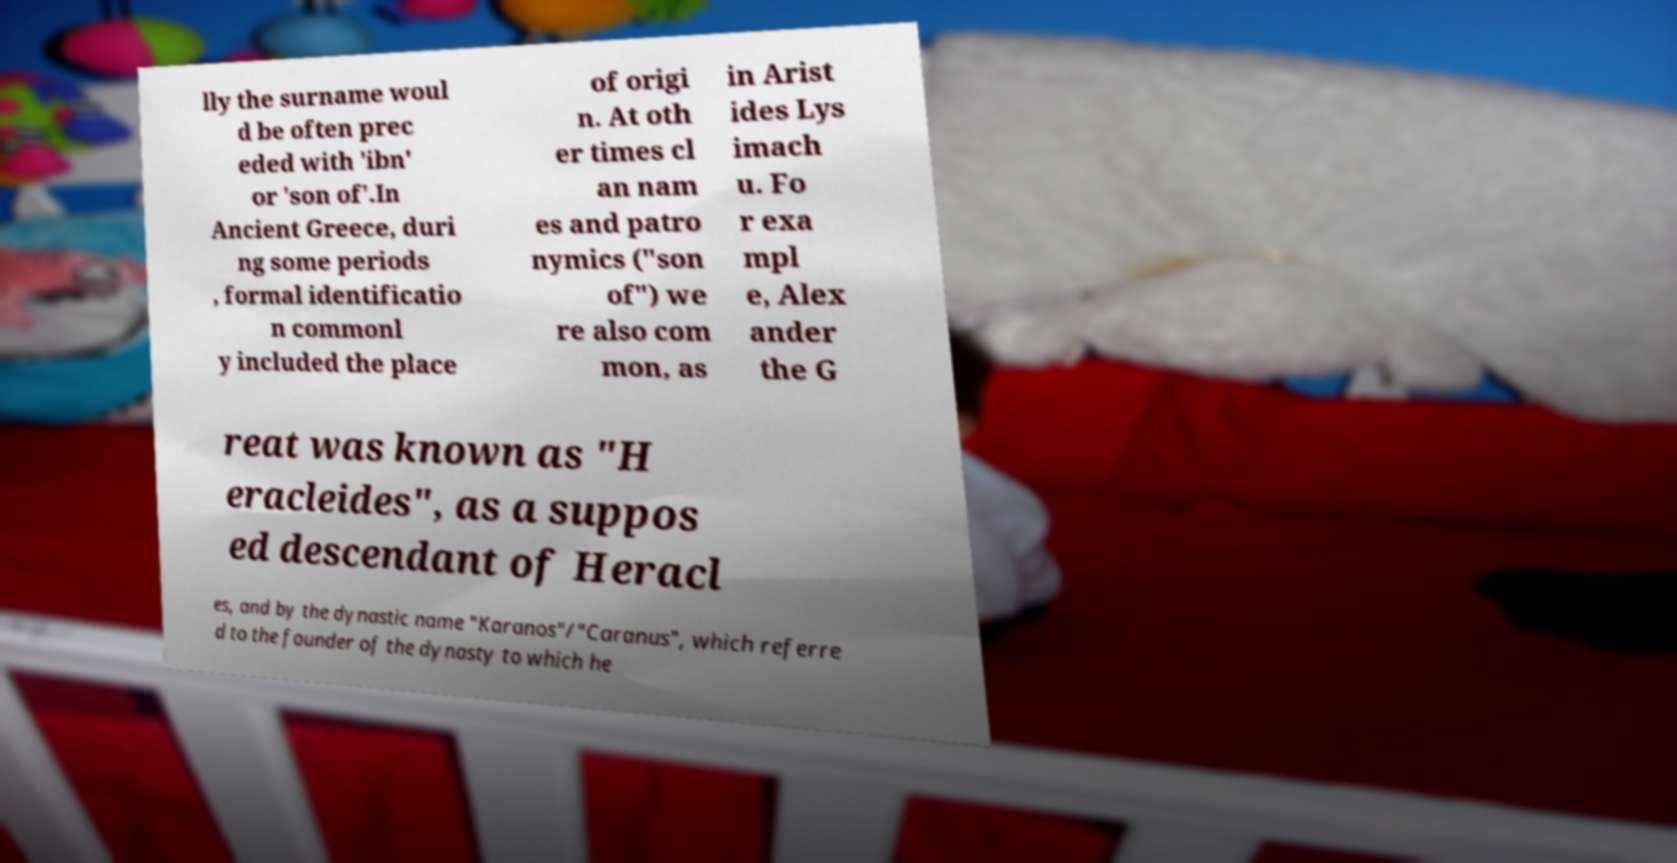Could you extract and type out the text from this image? lly the surname woul d be often prec eded with 'ibn' or 'son of'.In Ancient Greece, duri ng some periods , formal identificatio n commonl y included the place of origi n. At oth er times cl an nam es and patro nymics ("son of") we re also com mon, as in Arist ides Lys imach u. Fo r exa mpl e, Alex ander the G reat was known as "H eracleides", as a suppos ed descendant of Heracl es, and by the dynastic name "Karanos"/"Caranus", which referre d to the founder of the dynasty to which he 